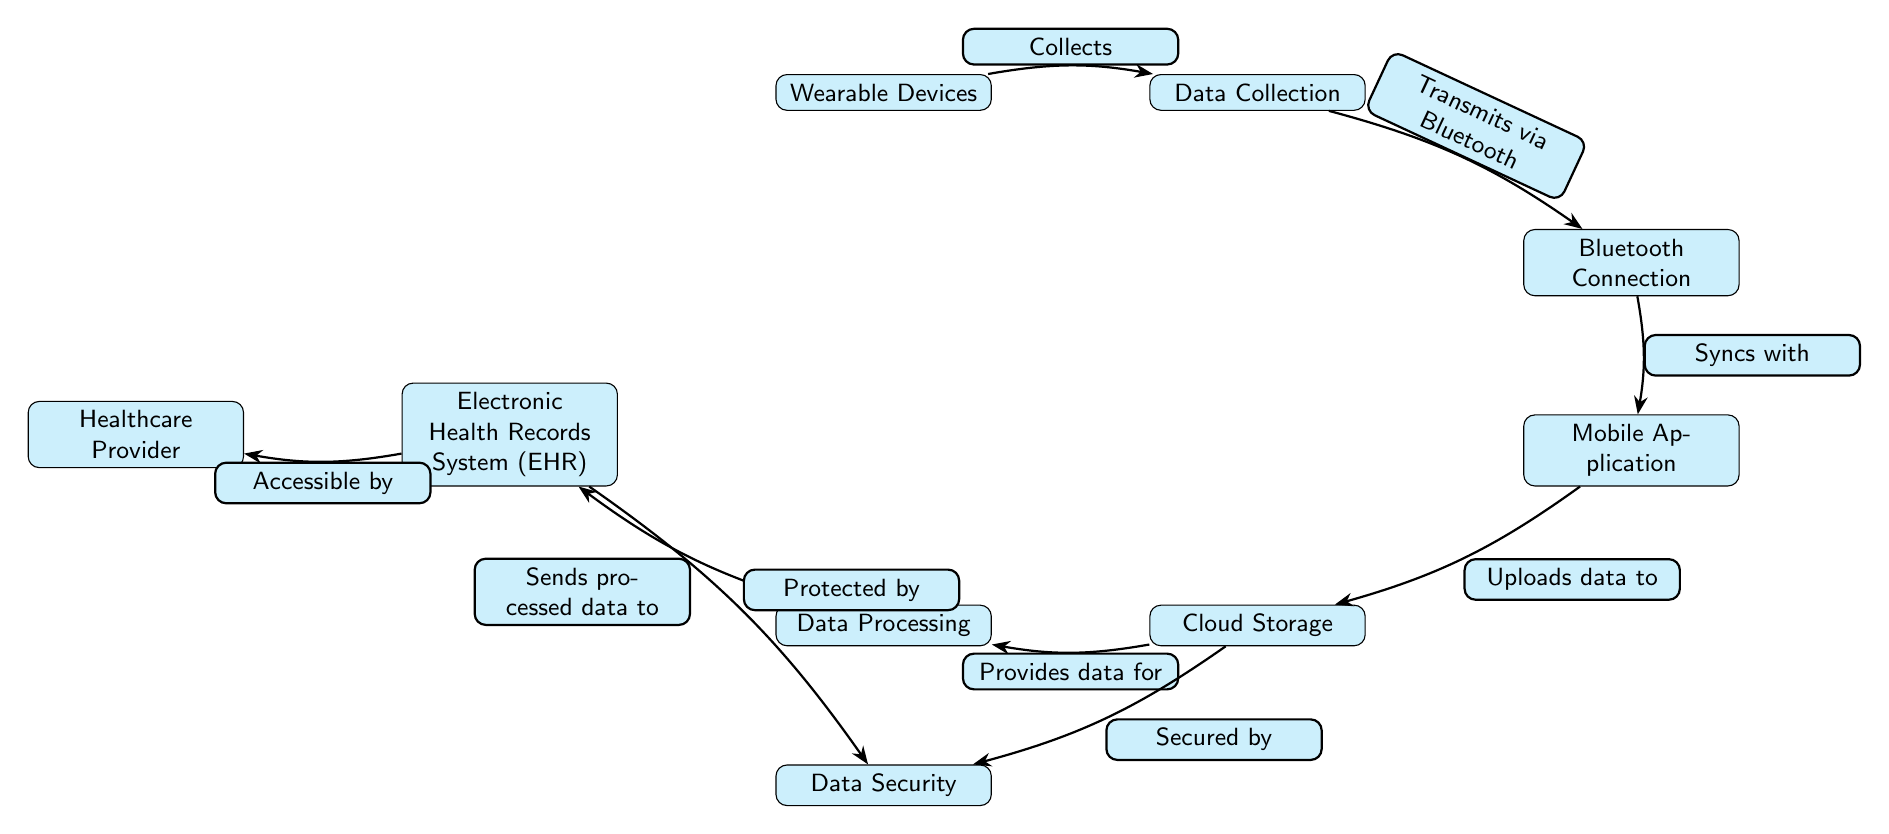What are the wearable devices responsible for? The diagram indicates that Wearable Devices are responsible for collecting data, as shown by the edge labeled "Collects" leading to the Data Collection node.
Answer: Collects How does data transmission occur from the data collection? The diagram shows that data transmission occurs via Bluetooth, as indicated by the edge labeled "Transmits via Bluetooth" between the Data Collection and Bluetooth Connection nodes.
Answer: Bluetooth Which system is the healthcare provider able to access? According to the diagram, the healthcare provider has access to the Electronic Health Records System (EHR), as shown by the edge labeled "Accessible by" leading from the EHR node to the Healthcare Provider node.
Answer: Electronic Health Records System What functions are performed after data is uploaded to cloud storage? After data is uploaded to cloud storage, the diagram shows that data processing occurs, as indicated by the edge labeled "Provides data for" leading from Cloud Storage to Data Processing.
Answer: Data Processing What secures the cloud storage? The diagram specifies that data security secures the cloud storage, as shown by the edge labeled "Secured by" leading from Cloud Storage to Data Security.
Answer: Data Security How many main components are shown in this diagram? The diagram features a total of eight main components (nodes): Wearable Devices, Data Collection, Bluetooth Connection, Mobile Application, Cloud Storage, Data Processing, Electronic Health Records System (EHR), and Healthcare Provider.
Answer: Eight What is the role of data processing in this system? The role of Data Processing, according to the diagram, is to send processed data to the Electronic Health Records System (EHR), as indicated by the edge labeled "Sends processed data to" leading from Data Processing to EHR.
Answer: Sends processed data to What two elements share data security protection? The diagram indicates that both the Cloud Storage and Electronic Health Records System (EHR) are protected by data security, as shown by the edges labeled "Secured by" and "Protected by" respectively.
Answer: Cloud Storage and Electronic Health Records System What connection method is depicted between Bluetooth and the mobile application? The connection method between Bluetooth Connection and Mobile Application is described by the edge labeled "Syncs with" in the diagram.
Answer: Syncs with 